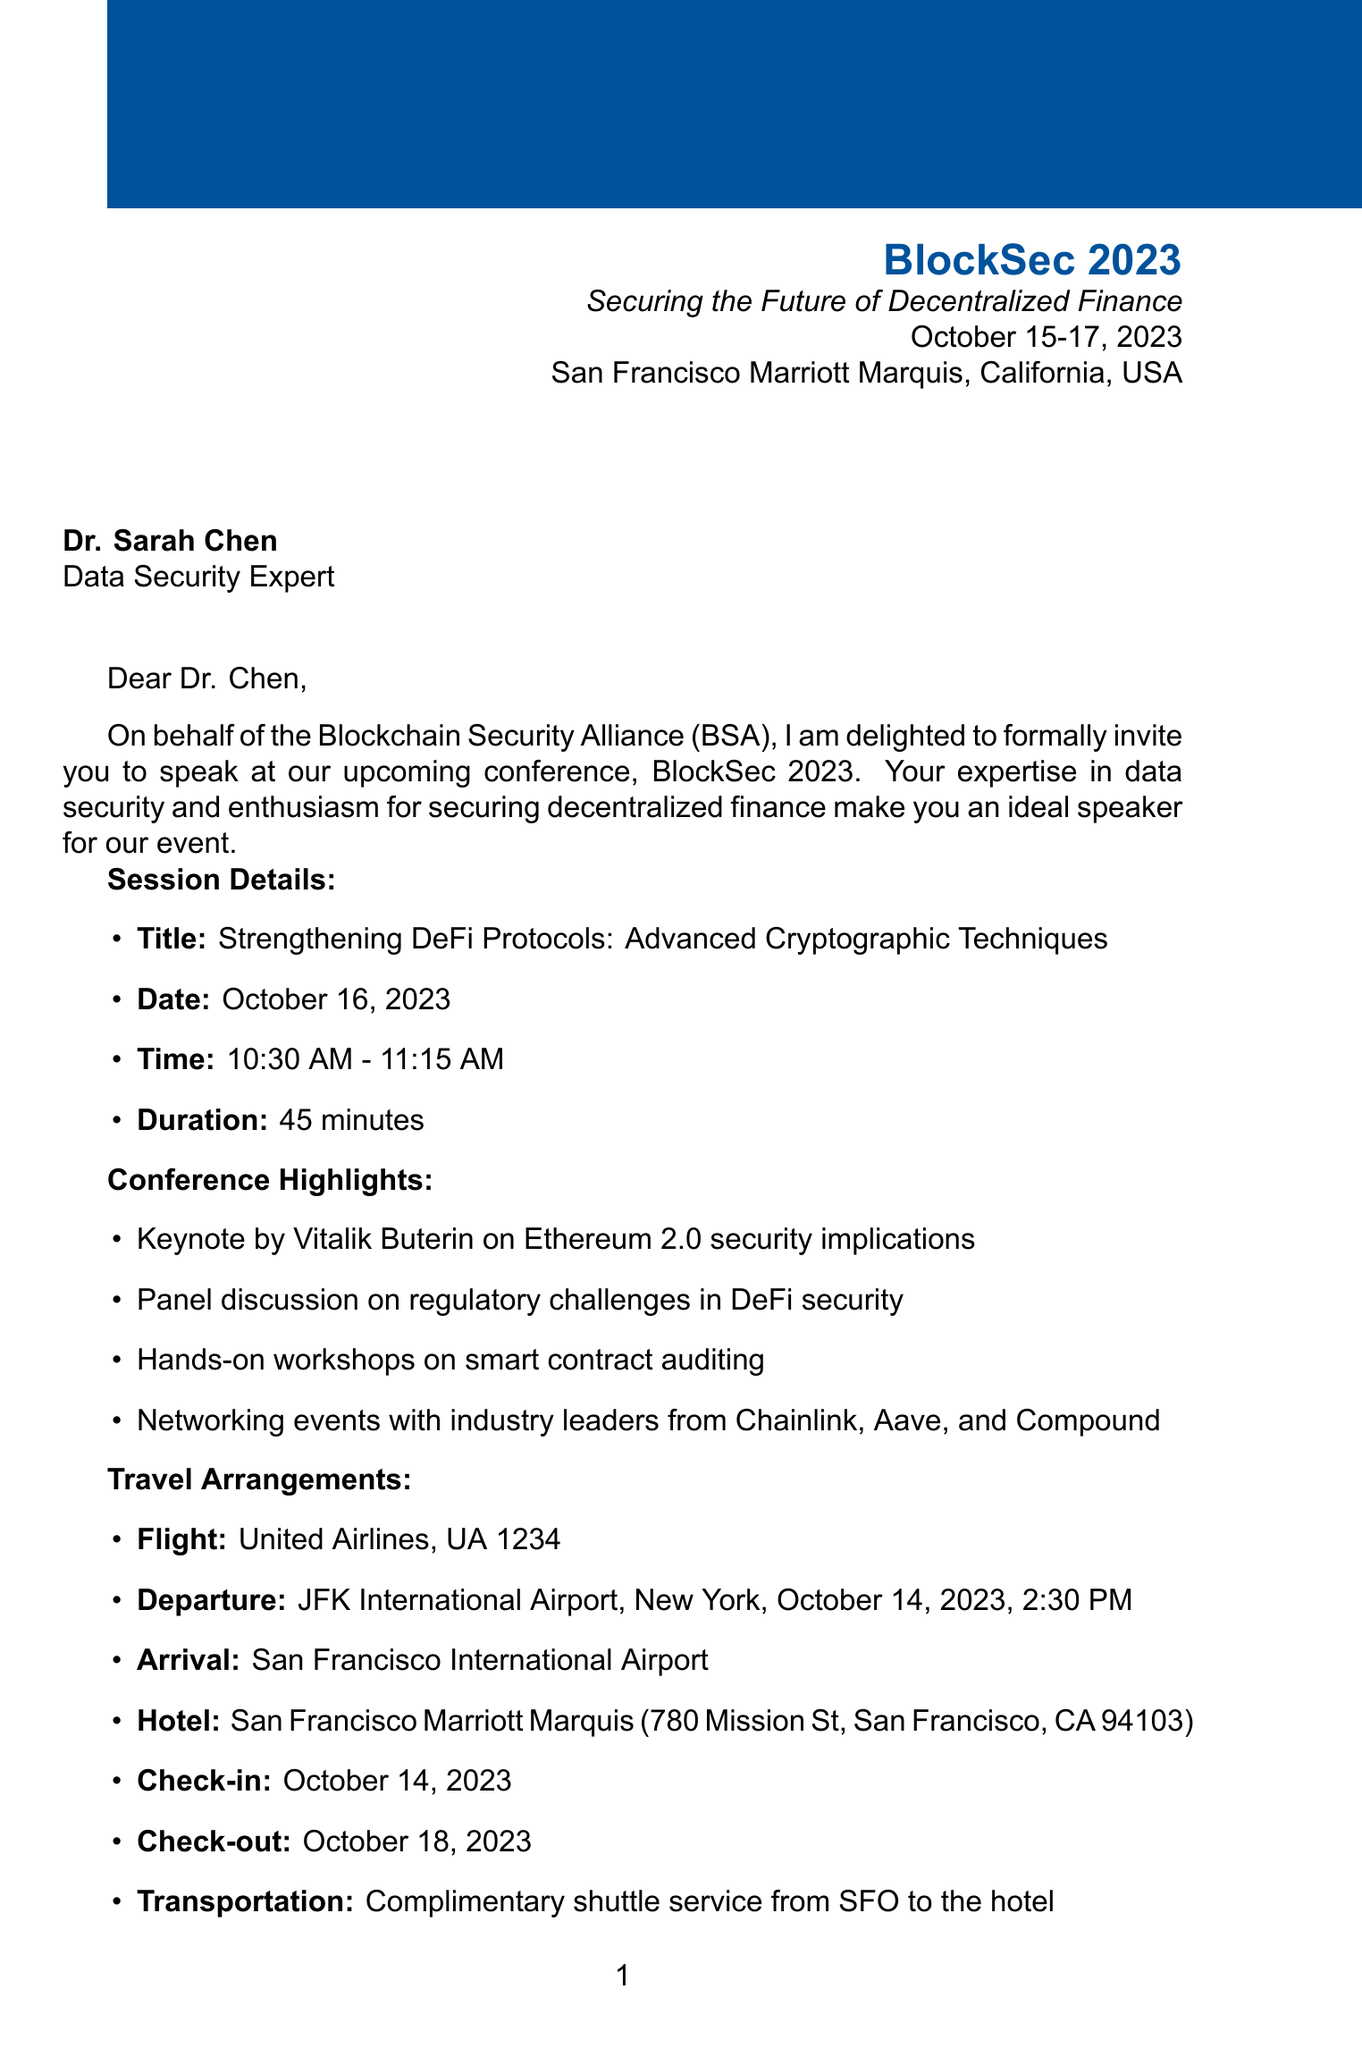What is the conference name? The conference name is mentioned at the beginning of the document.
Answer: BlockSec 2023: Securing the Future of Decentralized Finance What are the event dates? The event dates are specified in the introduction of the document.
Answer: October 15-17, 2023 Who is the speaker? The speaker's name is listed in the invitation details section.
Answer: Dr. Sarah Chen What is the session title? The session title is included in the session details.
Answer: Strengthening DeFi Protocols: Advanced Cryptographic Techniques What is the honorarium amount for the speaker? The honorarium is stated in the speaker benefits section.
Answer: $1,500 When is Dr. Sarah Chen's session scheduled? The session date is mentioned in the session details.
Answer: October 16, 2023 What airline is used for the travel arrangements? The airline is specifically mentioned in the travel arrangements section.
Answer: United Airlines What is included in the speaker benefits? The benefits for the speaker are detailed in the respective section.
Answer: Full conference pass, VIP access to exclusive networking events, Honorarium of $1,500, Coverage of travel and accommodation expenses Who is the contact person for inquiries? The contact person is identified at the end of the document.
Answer: Emily Rodriguez What type of venue is the conference being held at? The venue type is indicated in the location information.
Answer: Marriott Hotel 